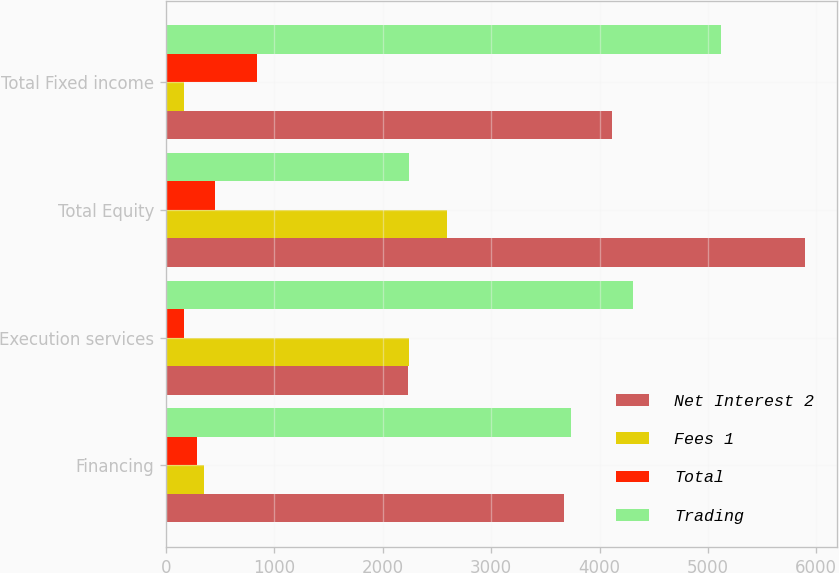Convert chart to OTSL. <chart><loc_0><loc_0><loc_500><loc_500><stacked_bar_chart><ecel><fcel>Financing<fcel>Execution services<fcel>Total Equity<fcel>Total Fixed income<nl><fcel>Net Interest 2<fcel>3668<fcel>2231<fcel>5899<fcel>4115<nl><fcel>Fees 1<fcel>347<fcel>2241<fcel>2588<fcel>162<nl><fcel>Total<fcel>283<fcel>167<fcel>450<fcel>840<nl><fcel>Trading<fcel>3732<fcel>4305<fcel>2241<fcel>5117<nl></chart> 